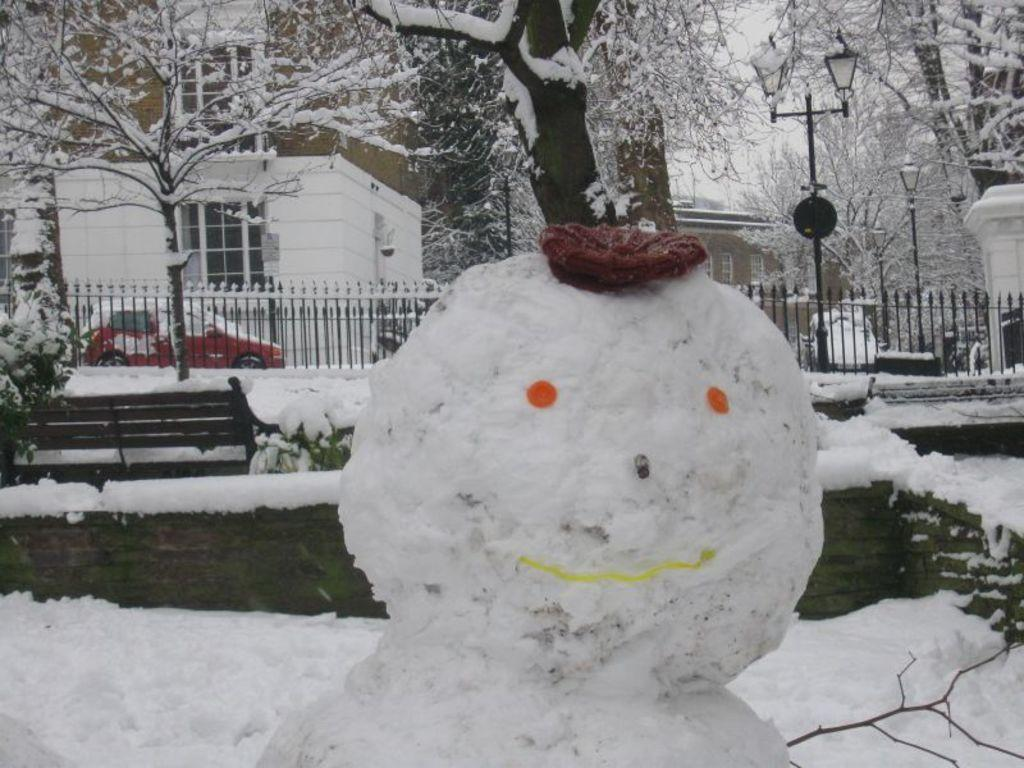What is the main subject of the image? There is a snowman in the image. What is the snowman wearing? The snowman is wearing a cap. What can be seen in the background of the image? In the background of the image, there are plants, a bench, snow, fences, a vehicle, buildings, trees, street lights, and walls. Are there any glass objects visible in the image? Yes, glass objects are visible in the background of the image. What type of butter is being spread on the cushion in the image? There is no butter or cushion present in the image; it features a snowman and various background elements. 